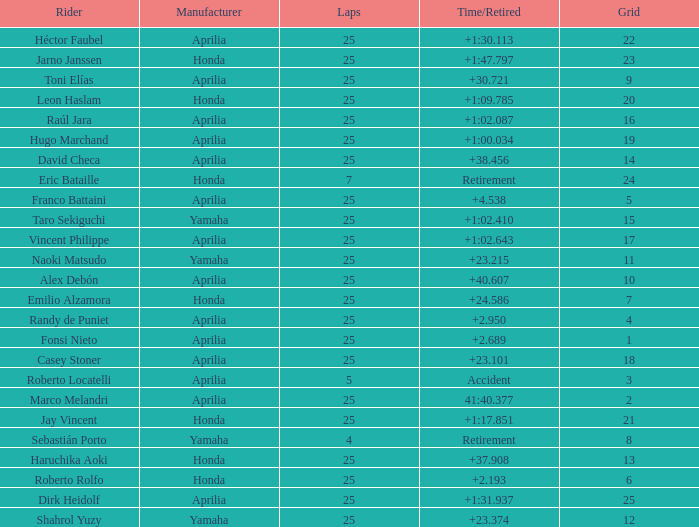Which Grid has Laps of 25, and a Manufacturer of honda, and a Time/Retired of +1:47.797? 23.0. 